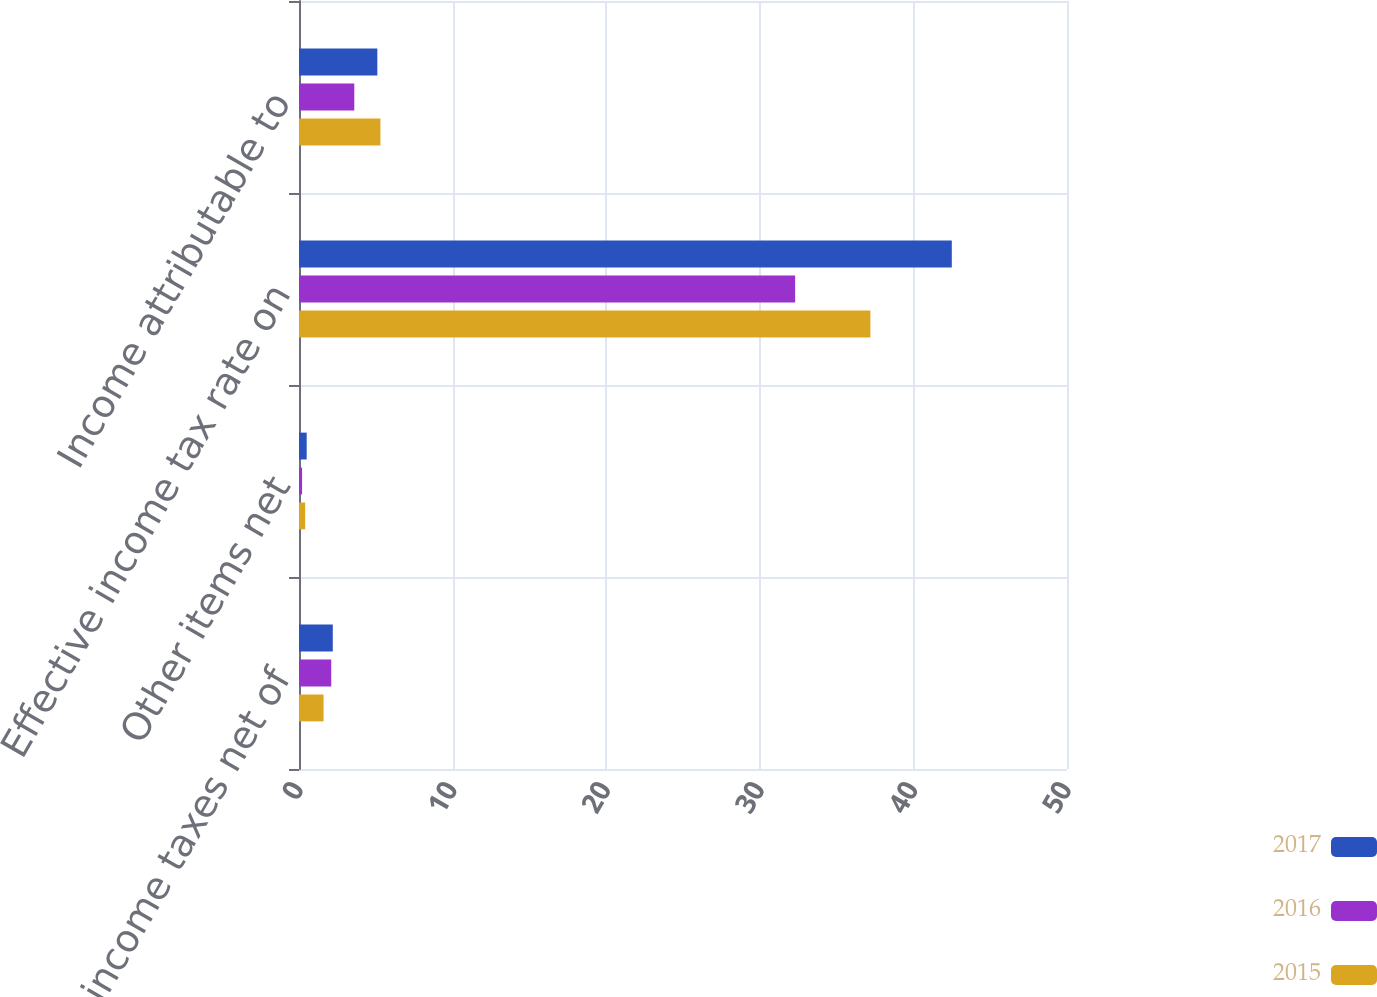<chart> <loc_0><loc_0><loc_500><loc_500><stacked_bar_chart><ecel><fcel>State income taxes net of<fcel>Other items net<fcel>Effective income tax rate on<fcel>Income attributable to<nl><fcel>2017<fcel>2.2<fcel>0.5<fcel>42.5<fcel>5.1<nl><fcel>2016<fcel>2.1<fcel>0.2<fcel>32.3<fcel>3.6<nl><fcel>2015<fcel>1.6<fcel>0.4<fcel>37.2<fcel>5.3<nl></chart> 